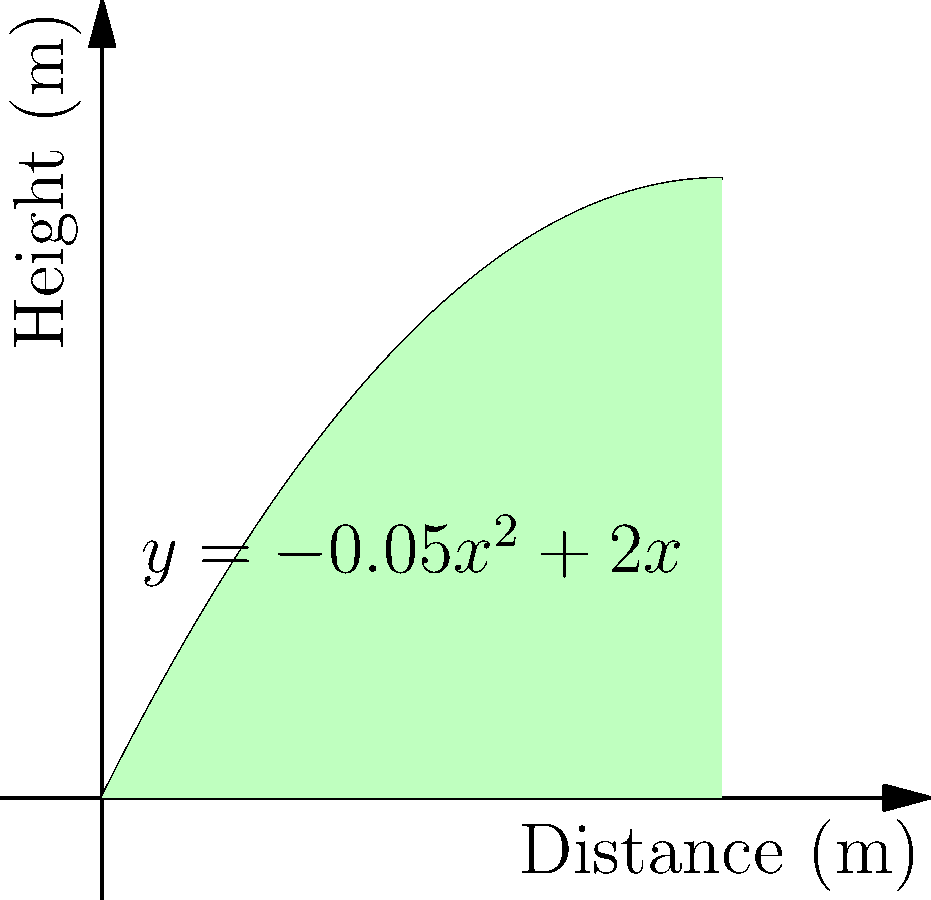A sniper fires a projectile with an initial velocity that results in a trajectory described by the function $y = -0.05x^2 + 2x$, where $y$ is the height in meters and $x$ is the horizontal distance in meters. Calculate the time of flight by estimating the area under the curve using the trapezoidal rule with 4 equal subdivisions. Assume $g = 9.8 m/s^2$. To solve this problem, we'll follow these steps:

1) First, we need to find the range (where the projectile hits the ground). Set $y = 0$:
   $0 = -0.05x^2 + 2x$
   $0.05x^2 - 2x = 0$
   $x(0.05x - 2) = 0$
   $x = 0$ or $x = 40$
   The range is 40 meters.

2) Divide the range into 4 equal subdivisions:
   $\Delta x = 40/4 = 10$ meters

3) Calculate $y$ values at $x = 0, 10, 20, 30, 40$:
   $f(0) = 0$
   $f(10) = -0.05(10)^2 + 2(10) = 15$
   $f(20) = -0.05(20)^2 + 2(20) = 20$
   $f(30) = -0.05(30)^2 + 2(30) = 15$
   $f(40) = -0.05(40)^2 + 2(40) = 0$

4) Apply the trapezoidal rule:
   Area $\approx \frac{\Delta x}{2}[f(0) + 2f(10) + 2f(20) + 2f(30) + f(40)]$
   $= \frac{10}{2}[0 + 2(15) + 2(20) + 2(15) + 0]$
   $= 5[30 + 40 + 30]$
   $= 5(100) = 500$ square meters

5) The area under the curve represents the horizontal distance traveled multiplied by the average height. If we divide this by the range, we get the average height:
   Average height $= 500/40 = 12.5$ meters

6) We can use the equation $h = \frac{1}{2}gt^2$ to find the time, where $h$ is the average height:
   $12.5 = \frac{1}{2}(9.8)t^2$
   $t^2 = \frac{2(12.5)}{9.8} = 2.55$
   $t = \sqrt{2.55} \approx 1.60$ seconds

Therefore, the estimated time of flight is approximately 1.60 seconds.
Answer: 1.60 seconds 